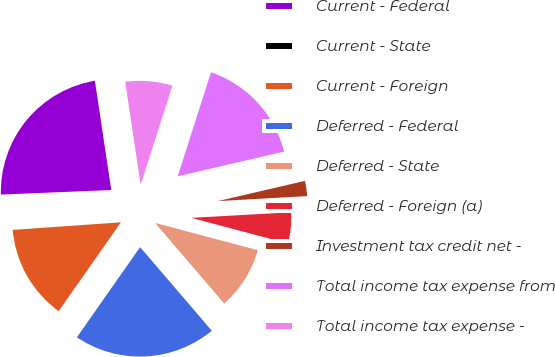Convert chart to OTSL. <chart><loc_0><loc_0><loc_500><loc_500><pie_chart><fcel>Current - Federal<fcel>Current - State<fcel>Current - Foreign<fcel>Deferred - Federal<fcel>Deferred - State<fcel>Deferred - Foreign (a)<fcel>Investment tax credit net -<fcel>Total income tax expense from<fcel>Total income tax expense -<nl><fcel>23.29%<fcel>0.45%<fcel>14.16%<fcel>21.01%<fcel>9.59%<fcel>5.02%<fcel>2.74%<fcel>16.44%<fcel>7.3%<nl></chart> 